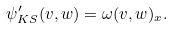Convert formula to latex. <formula><loc_0><loc_0><loc_500><loc_500>\psi ^ { \prime } _ { K S } ( v , w ) = \omega ( v , w ) _ { x } .</formula> 